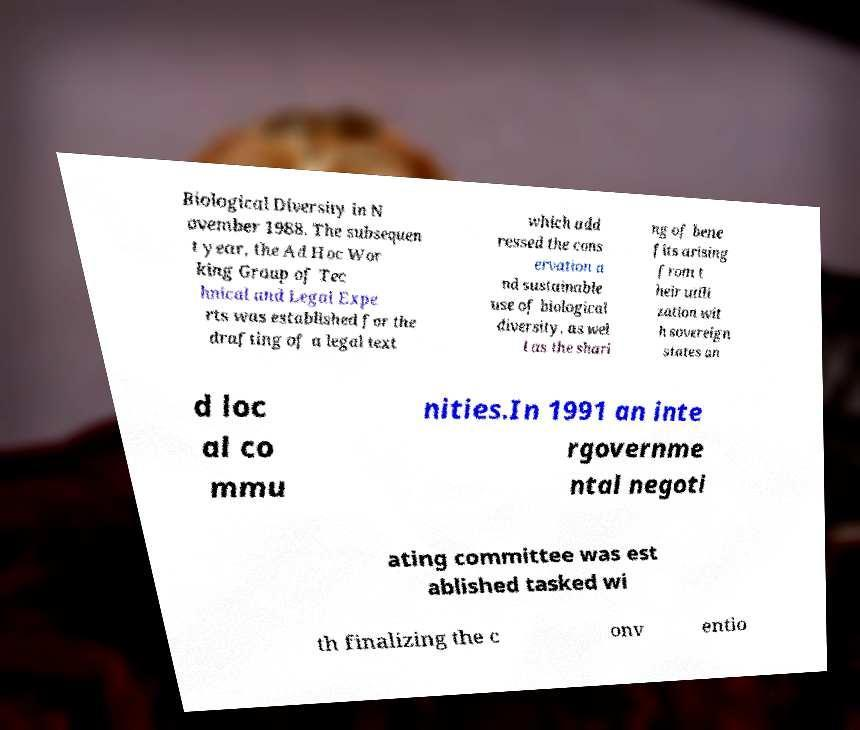Can you read and provide the text displayed in the image?This photo seems to have some interesting text. Can you extract and type it out for me? Biological Diversity in N ovember 1988. The subsequen t year, the Ad Hoc Wor king Group of Tec hnical and Legal Expe rts was established for the drafting of a legal text which add ressed the cons ervation a nd sustainable use of biological diversity, as wel l as the shari ng of bene fits arising from t heir utili zation wit h sovereign states an d loc al co mmu nities.In 1991 an inte rgovernme ntal negoti ating committee was est ablished tasked wi th finalizing the c onv entio 